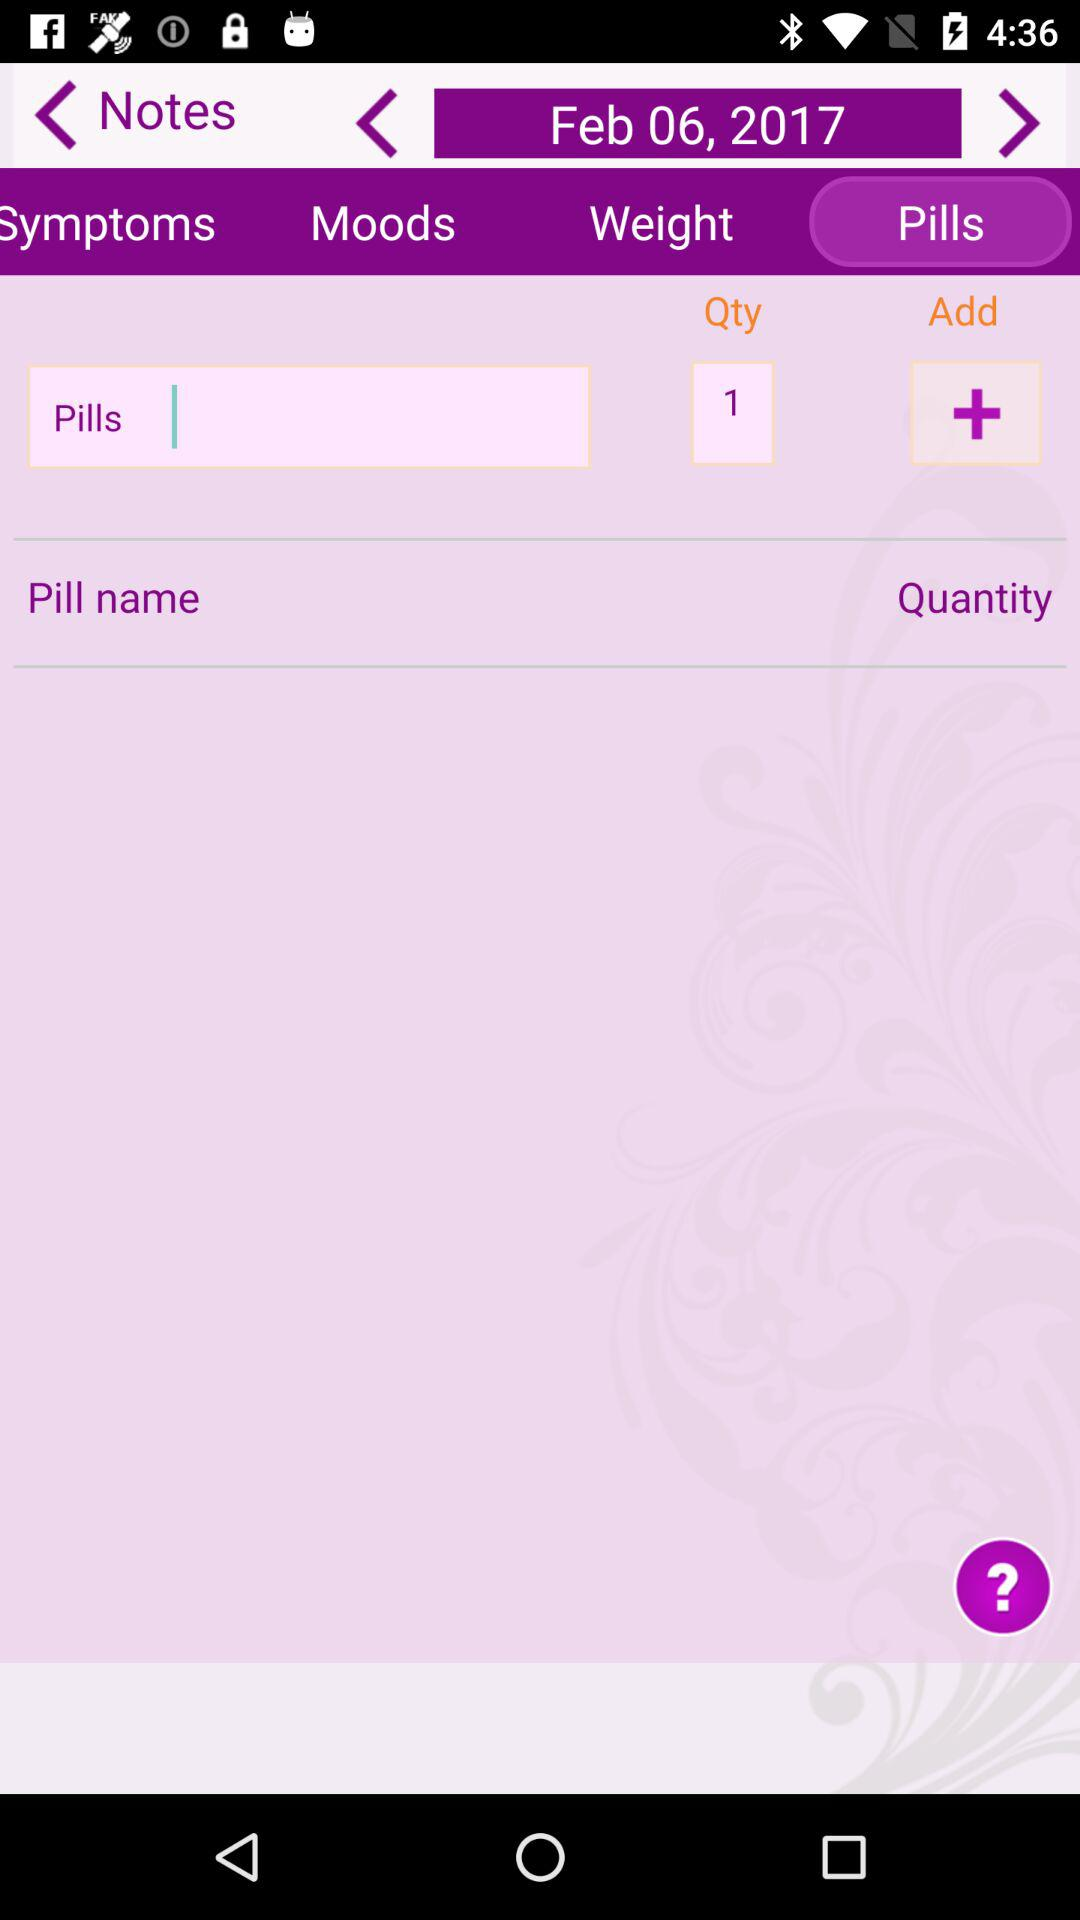How many more pills are there than the quantity?
Answer the question using a single word or phrase. 0 